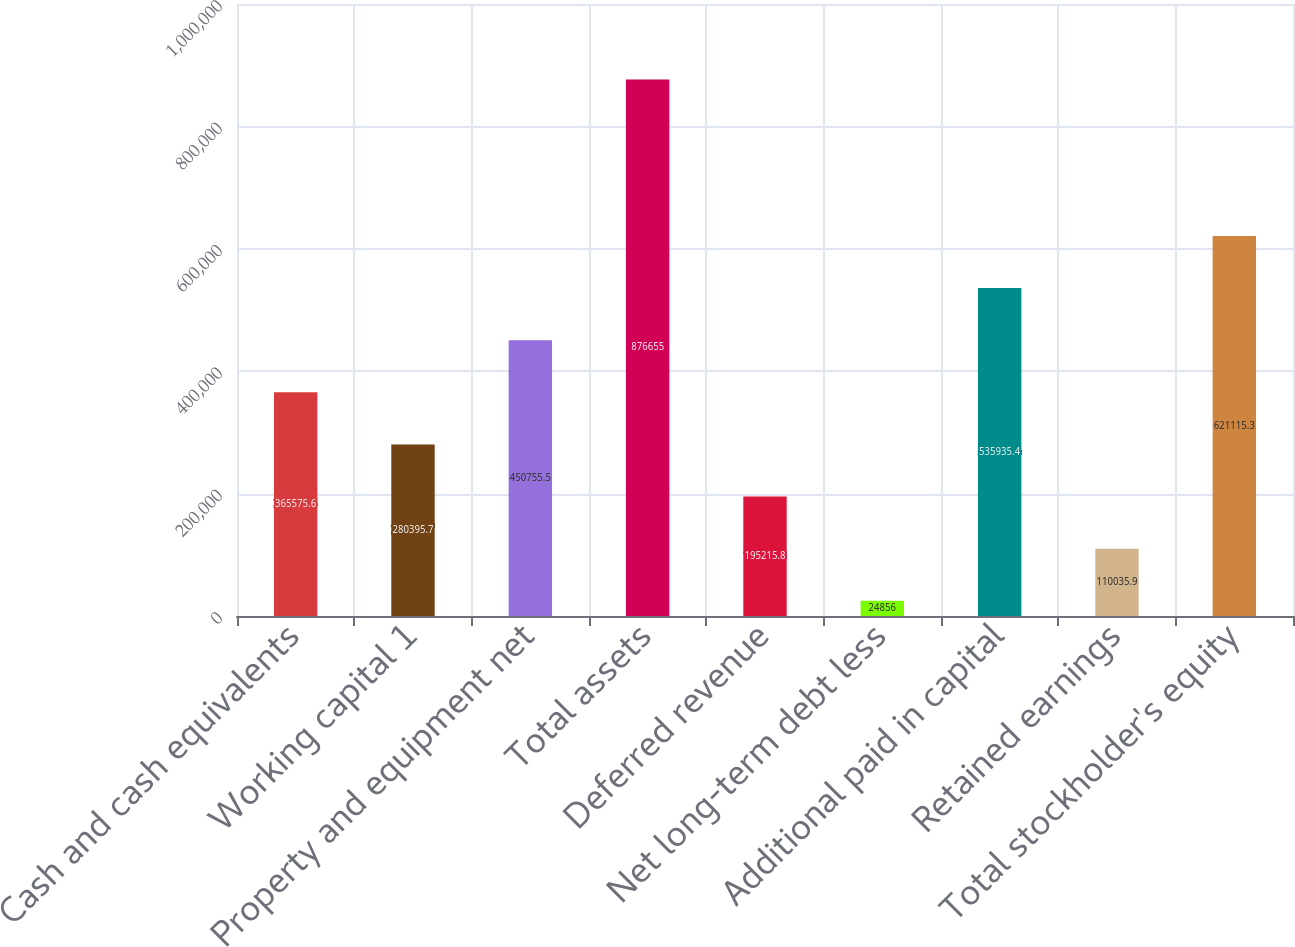Convert chart. <chart><loc_0><loc_0><loc_500><loc_500><bar_chart><fcel>Cash and cash equivalents<fcel>Working capital 1<fcel>Property and equipment net<fcel>Total assets<fcel>Deferred revenue<fcel>Net long-term debt less<fcel>Additional paid in capital<fcel>Retained earnings<fcel>Total stockholder's equity<nl><fcel>365576<fcel>280396<fcel>450756<fcel>876655<fcel>195216<fcel>24856<fcel>535935<fcel>110036<fcel>621115<nl></chart> 